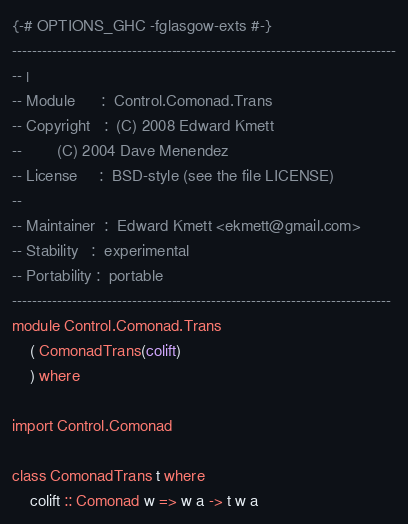Convert code to text. <code><loc_0><loc_0><loc_500><loc_500><_Haskell_>{-# OPTIONS_GHC -fglasgow-exts #-}
-----------------------------------------------------------------------------
-- |
-- Module      :  Control.Comonad.Trans
-- Copyright   :  (C) 2008 Edward Kmett
--		  (C) 2004 Dave Menendez
-- License     :  BSD-style (see the file LICENSE)
--
-- Maintainer  :  Edward Kmett <ekmett@gmail.com>
-- Stability   :  experimental
-- Portability :  portable
----------------------------------------------------------------------------
module Control.Comonad.Trans
	( ComonadTrans(colift)
	) where

import Control.Comonad

class ComonadTrans t where
	colift :: Comonad w => w a -> t w a 
</code> 